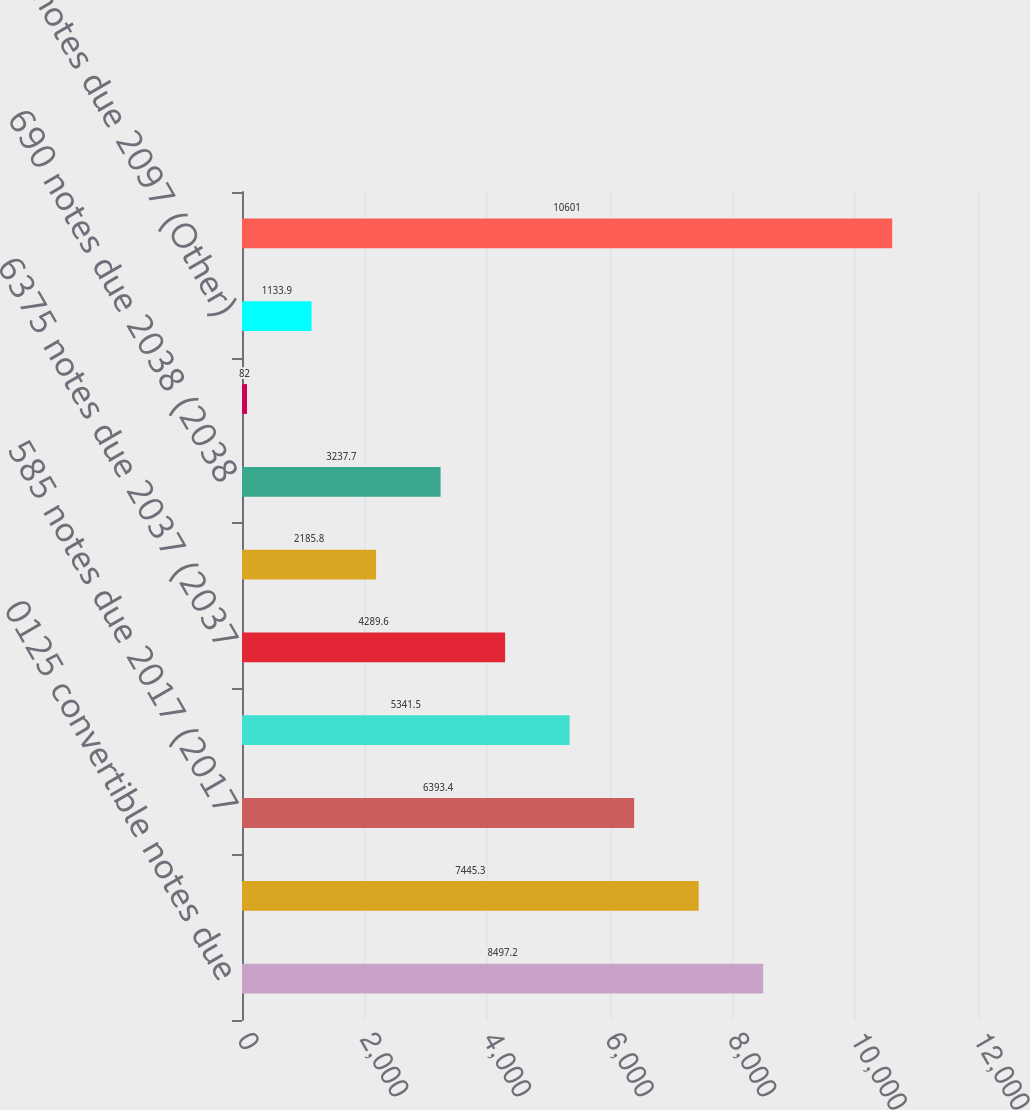<chart> <loc_0><loc_0><loc_500><loc_500><bar_chart><fcel>0125 convertible notes due<fcel>0375 convertible notes due<fcel>585 notes due 2017 (2017<fcel>485 notes due 2014 (2014<fcel>6375 notes due 2037 (2037<fcel>615 notes due 2018 (2018<fcel>690 notes due 2038 (2038<fcel>Zero-coupon modified<fcel>8125 notes due 2097 (Other)<fcel>Total borrowings<nl><fcel>8497.2<fcel>7445.3<fcel>6393.4<fcel>5341.5<fcel>4289.6<fcel>2185.8<fcel>3237.7<fcel>82<fcel>1133.9<fcel>10601<nl></chart> 